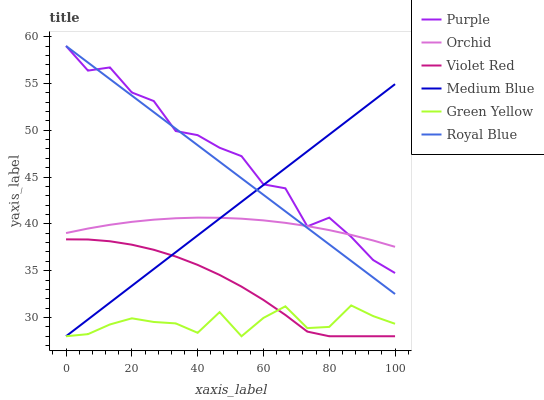Does Green Yellow have the minimum area under the curve?
Answer yes or no. Yes. Does Purple have the maximum area under the curve?
Answer yes or no. Yes. Does Medium Blue have the minimum area under the curve?
Answer yes or no. No. Does Medium Blue have the maximum area under the curve?
Answer yes or no. No. Is Medium Blue the smoothest?
Answer yes or no. Yes. Is Purple the roughest?
Answer yes or no. Yes. Is Purple the smoothest?
Answer yes or no. No. Is Medium Blue the roughest?
Answer yes or no. No. Does Violet Red have the lowest value?
Answer yes or no. Yes. Does Purple have the lowest value?
Answer yes or no. No. Does Royal Blue have the highest value?
Answer yes or no. Yes. Does Medium Blue have the highest value?
Answer yes or no. No. Is Green Yellow less than Orchid?
Answer yes or no. Yes. Is Orchid greater than Violet Red?
Answer yes or no. Yes. Does Green Yellow intersect Medium Blue?
Answer yes or no. Yes. Is Green Yellow less than Medium Blue?
Answer yes or no. No. Is Green Yellow greater than Medium Blue?
Answer yes or no. No. Does Green Yellow intersect Orchid?
Answer yes or no. No. 